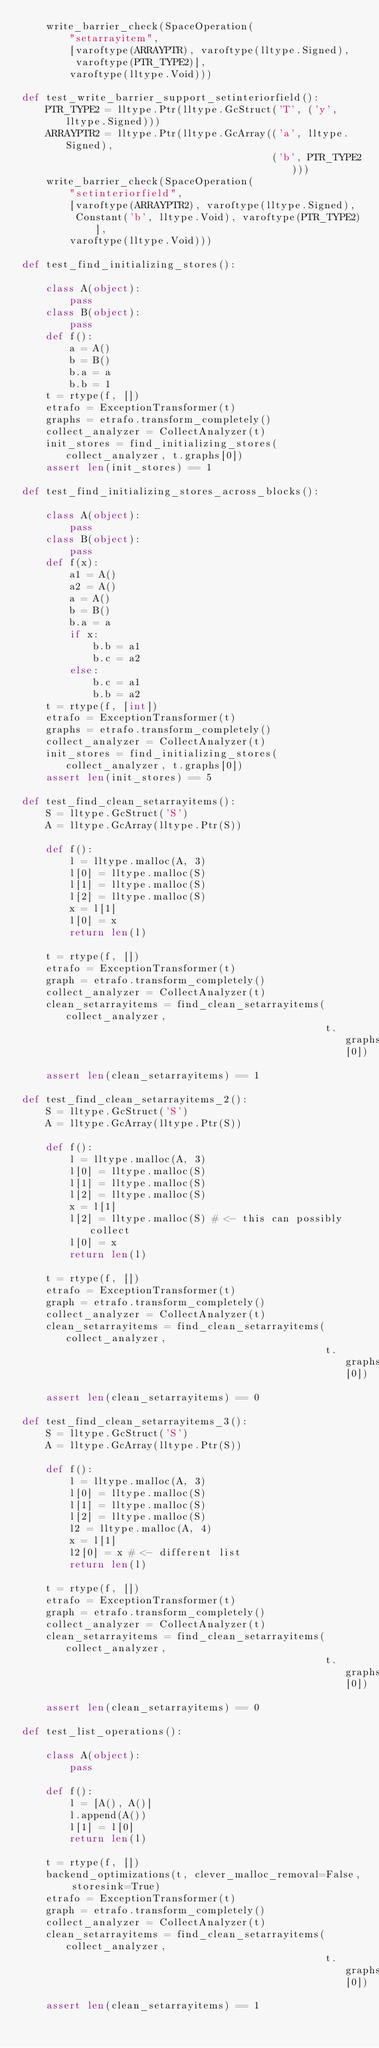Convert code to text. <code><loc_0><loc_0><loc_500><loc_500><_Python_>    write_barrier_check(SpaceOperation(
        "setarrayitem",
        [varoftype(ARRAYPTR), varoftype(lltype.Signed),
         varoftype(PTR_TYPE2)],
        varoftype(lltype.Void)))

def test_write_barrier_support_setinteriorfield():
    PTR_TYPE2 = lltype.Ptr(lltype.GcStruct('T', ('y', lltype.Signed)))
    ARRAYPTR2 = lltype.Ptr(lltype.GcArray(('a', lltype.Signed),
                                          ('b', PTR_TYPE2)))
    write_barrier_check(SpaceOperation(
        "setinteriorfield",
        [varoftype(ARRAYPTR2), varoftype(lltype.Signed),
         Constant('b', lltype.Void), varoftype(PTR_TYPE2)],
        varoftype(lltype.Void)))

def test_find_initializing_stores():

    class A(object):
        pass
    class B(object):
        pass
    def f():
        a = A()
        b = B()
        b.a = a
        b.b = 1
    t = rtype(f, [])
    etrafo = ExceptionTransformer(t)
    graphs = etrafo.transform_completely()
    collect_analyzer = CollectAnalyzer(t)
    init_stores = find_initializing_stores(collect_analyzer, t.graphs[0])
    assert len(init_stores) == 1

def test_find_initializing_stores_across_blocks():

    class A(object):
        pass
    class B(object):
        pass
    def f(x):
        a1 = A()
        a2 = A()
        a = A()
        b = B()
        b.a = a
        if x:
            b.b = a1
            b.c = a2
        else:
            b.c = a1
            b.b = a2
    t = rtype(f, [int])
    etrafo = ExceptionTransformer(t)
    graphs = etrafo.transform_completely()
    collect_analyzer = CollectAnalyzer(t)
    init_stores = find_initializing_stores(collect_analyzer, t.graphs[0])
    assert len(init_stores) == 5

def test_find_clean_setarrayitems():
    S = lltype.GcStruct('S')
    A = lltype.GcArray(lltype.Ptr(S))
    
    def f():
        l = lltype.malloc(A, 3)
        l[0] = lltype.malloc(S)
        l[1] = lltype.malloc(S)
        l[2] = lltype.malloc(S)
        x = l[1]
        l[0] = x
        return len(l)

    t = rtype(f, [])
    etrafo = ExceptionTransformer(t)
    graph = etrafo.transform_completely()
    collect_analyzer = CollectAnalyzer(t)
    clean_setarrayitems = find_clean_setarrayitems(collect_analyzer,
                                                   t.graphs[0])
    assert len(clean_setarrayitems) == 1

def test_find_clean_setarrayitems_2():
    S = lltype.GcStruct('S')
    A = lltype.GcArray(lltype.Ptr(S))
    
    def f():
        l = lltype.malloc(A, 3)
        l[0] = lltype.malloc(S)
        l[1] = lltype.malloc(S)
        l[2] = lltype.malloc(S)
        x = l[1]
        l[2] = lltype.malloc(S) # <- this can possibly collect
        l[0] = x
        return len(l)

    t = rtype(f, [])
    etrafo = ExceptionTransformer(t)
    graph = etrafo.transform_completely()
    collect_analyzer = CollectAnalyzer(t)
    clean_setarrayitems = find_clean_setarrayitems(collect_analyzer,
                                                   t.graphs[0])
    assert len(clean_setarrayitems) == 0

def test_find_clean_setarrayitems_3():
    S = lltype.GcStruct('S')
    A = lltype.GcArray(lltype.Ptr(S))
    
    def f():
        l = lltype.malloc(A, 3)
        l[0] = lltype.malloc(S)
        l[1] = lltype.malloc(S)
        l[2] = lltype.malloc(S)
        l2 = lltype.malloc(A, 4)
        x = l[1]
        l2[0] = x # <- different list
        return len(l)

    t = rtype(f, [])
    etrafo = ExceptionTransformer(t)
    graph = etrafo.transform_completely()
    collect_analyzer = CollectAnalyzer(t)
    clean_setarrayitems = find_clean_setarrayitems(collect_analyzer,
                                                   t.graphs[0])
    assert len(clean_setarrayitems) == 0

def test_list_operations():

    class A(object):
        pass

    def f():
        l = [A(), A()]
        l.append(A())
        l[1] = l[0]
        return len(l)

    t = rtype(f, [])
    backend_optimizations(t, clever_malloc_removal=False, storesink=True)
    etrafo = ExceptionTransformer(t)
    graph = etrafo.transform_completely()
    collect_analyzer = CollectAnalyzer(t)
    clean_setarrayitems = find_clean_setarrayitems(collect_analyzer,
                                                   t.graphs[0])
    assert len(clean_setarrayitems) == 1
</code> 